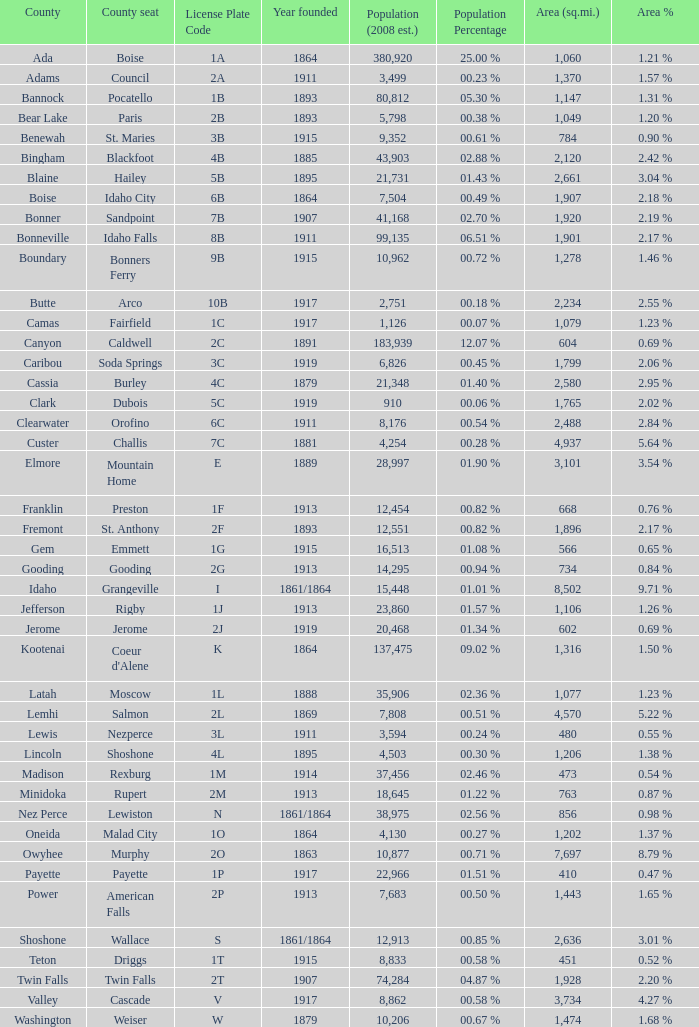What is the license plate code for the country with an area of 784? 3B. 